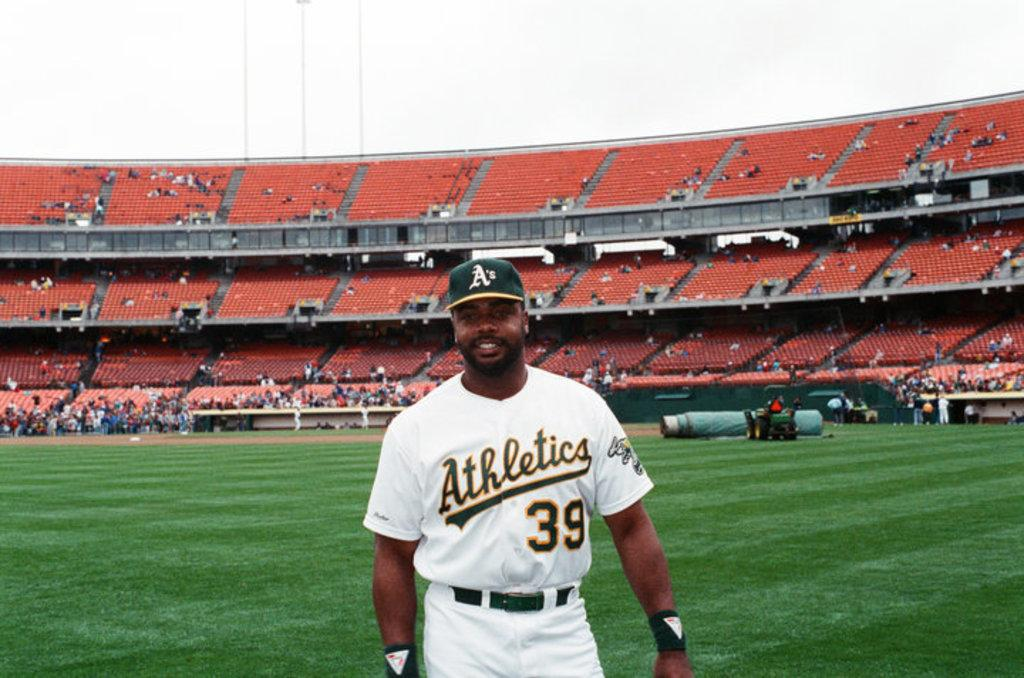<image>
Present a compact description of the photo's key features. Number 39 of the Oakland Athletics is shown on this player's jersey. 